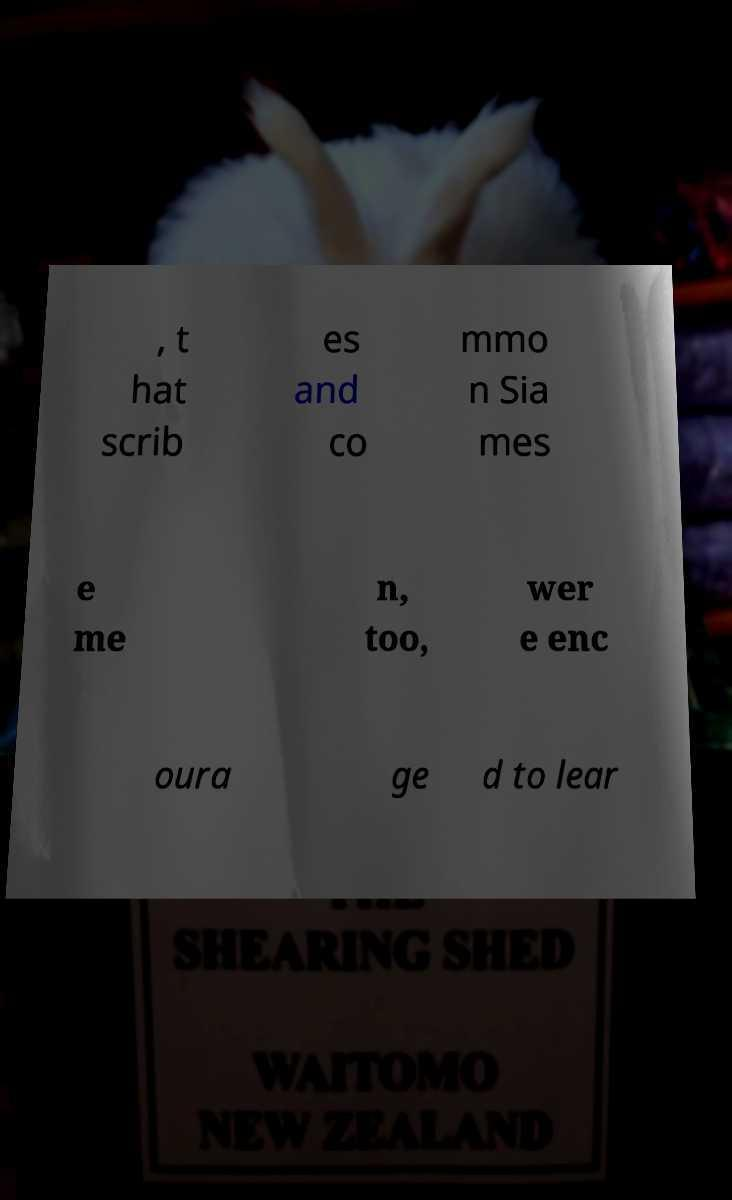I need the written content from this picture converted into text. Can you do that? , t hat scrib es and co mmo n Sia mes e me n, too, wer e enc oura ge d to lear 